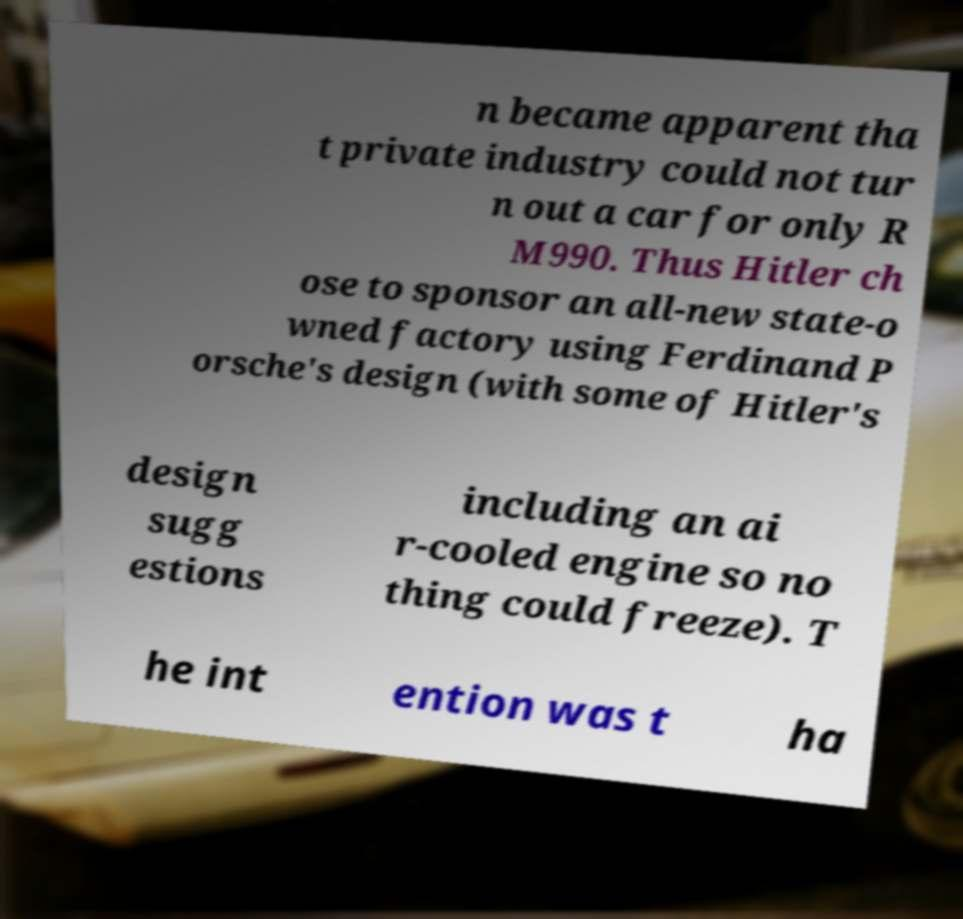Can you read and provide the text displayed in the image?This photo seems to have some interesting text. Can you extract and type it out for me? n became apparent tha t private industry could not tur n out a car for only R M990. Thus Hitler ch ose to sponsor an all-new state-o wned factory using Ferdinand P orsche's design (with some of Hitler's design sugg estions including an ai r-cooled engine so no thing could freeze). T he int ention was t ha 